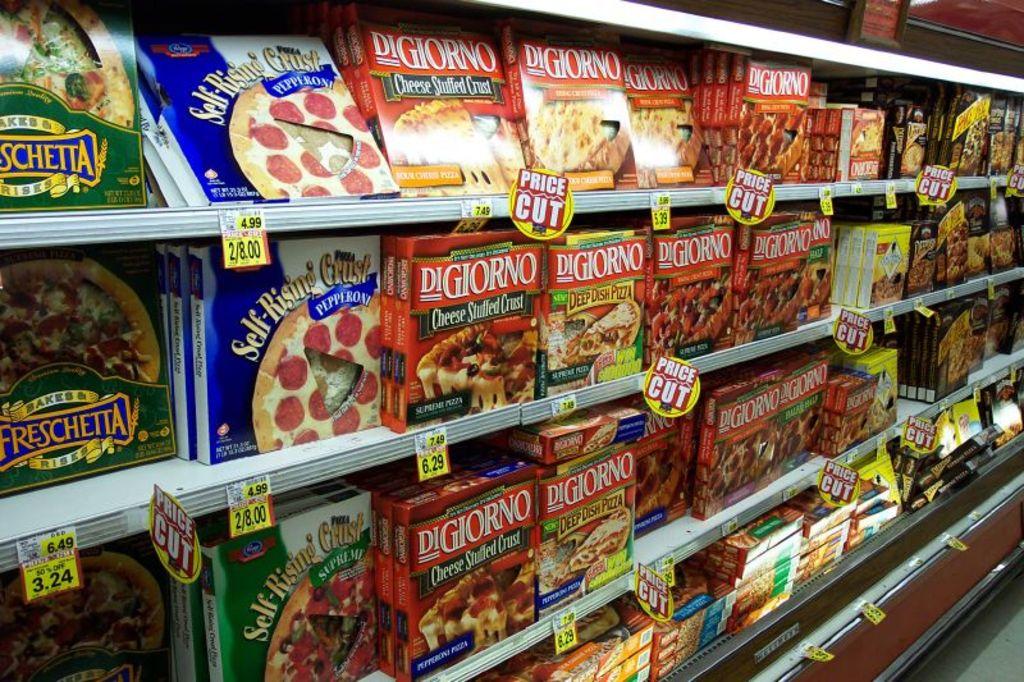What is the brand of pizza on the far left?
Your response must be concise. Freschetta. How much is the self-rising crust pepperoni pizza?
Give a very brief answer. 4.99. 